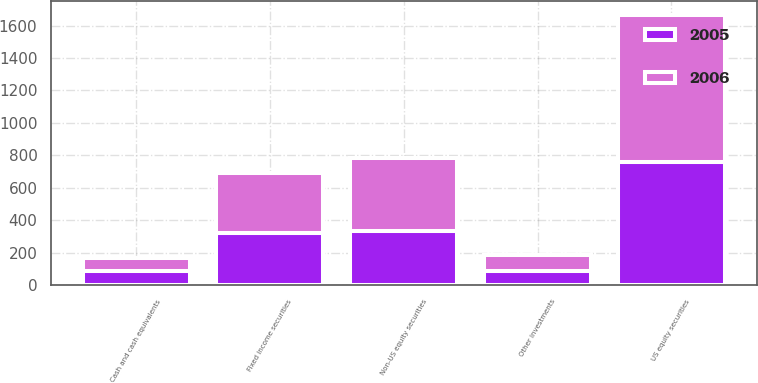Convert chart to OTSL. <chart><loc_0><loc_0><loc_500><loc_500><stacked_bar_chart><ecel><fcel>US equity securities<fcel>Non-US equity securities<fcel>Fixed income securities<fcel>Cash and cash equivalents<fcel>Other investments<nl><fcel>2006<fcel>905<fcel>449<fcel>374<fcel>85<fcel>100<nl><fcel>2005<fcel>761<fcel>334<fcel>320<fcel>86<fcel>87<nl></chart> 